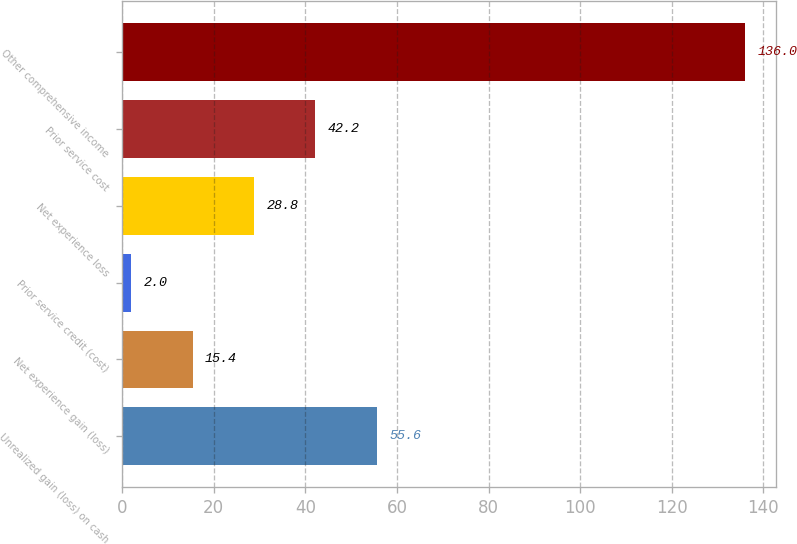Convert chart. <chart><loc_0><loc_0><loc_500><loc_500><bar_chart><fcel>Unrealized gain (loss) on cash<fcel>Net experience gain (loss)<fcel>Prior service credit (cost)<fcel>Net experience loss<fcel>Prior service cost<fcel>Other comprehensive income<nl><fcel>55.6<fcel>15.4<fcel>2<fcel>28.8<fcel>42.2<fcel>136<nl></chart> 